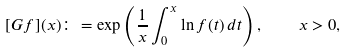Convert formula to latex. <formula><loc_0><loc_0><loc_500><loc_500>[ G f ] ( x ) \colon = \exp \left ( \frac { 1 } { x } \int _ { 0 } ^ { x } \ln f ( t ) \, d t \right ) , \quad x > 0 ,</formula> 